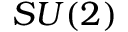Convert formula to latex. <formula><loc_0><loc_0><loc_500><loc_500>S U ( 2 )</formula> 